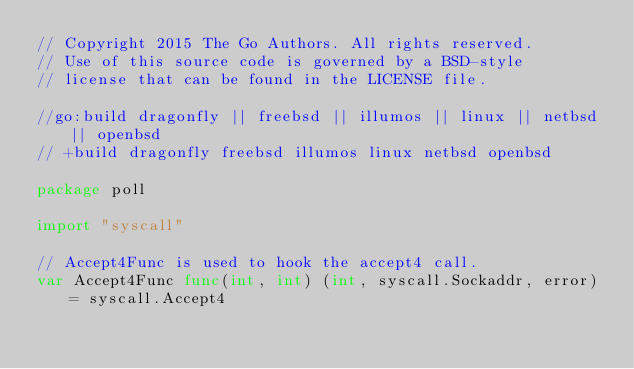<code> <loc_0><loc_0><loc_500><loc_500><_Go_>// Copyright 2015 The Go Authors. All rights reserved.
// Use of this source code is governed by a BSD-style
// license that can be found in the LICENSE file.

//go:build dragonfly || freebsd || illumos || linux || netbsd || openbsd
// +build dragonfly freebsd illumos linux netbsd openbsd

package poll

import "syscall"

// Accept4Func is used to hook the accept4 call.
var Accept4Func func(int, int) (int, syscall.Sockaddr, error) = syscall.Accept4
</code> 